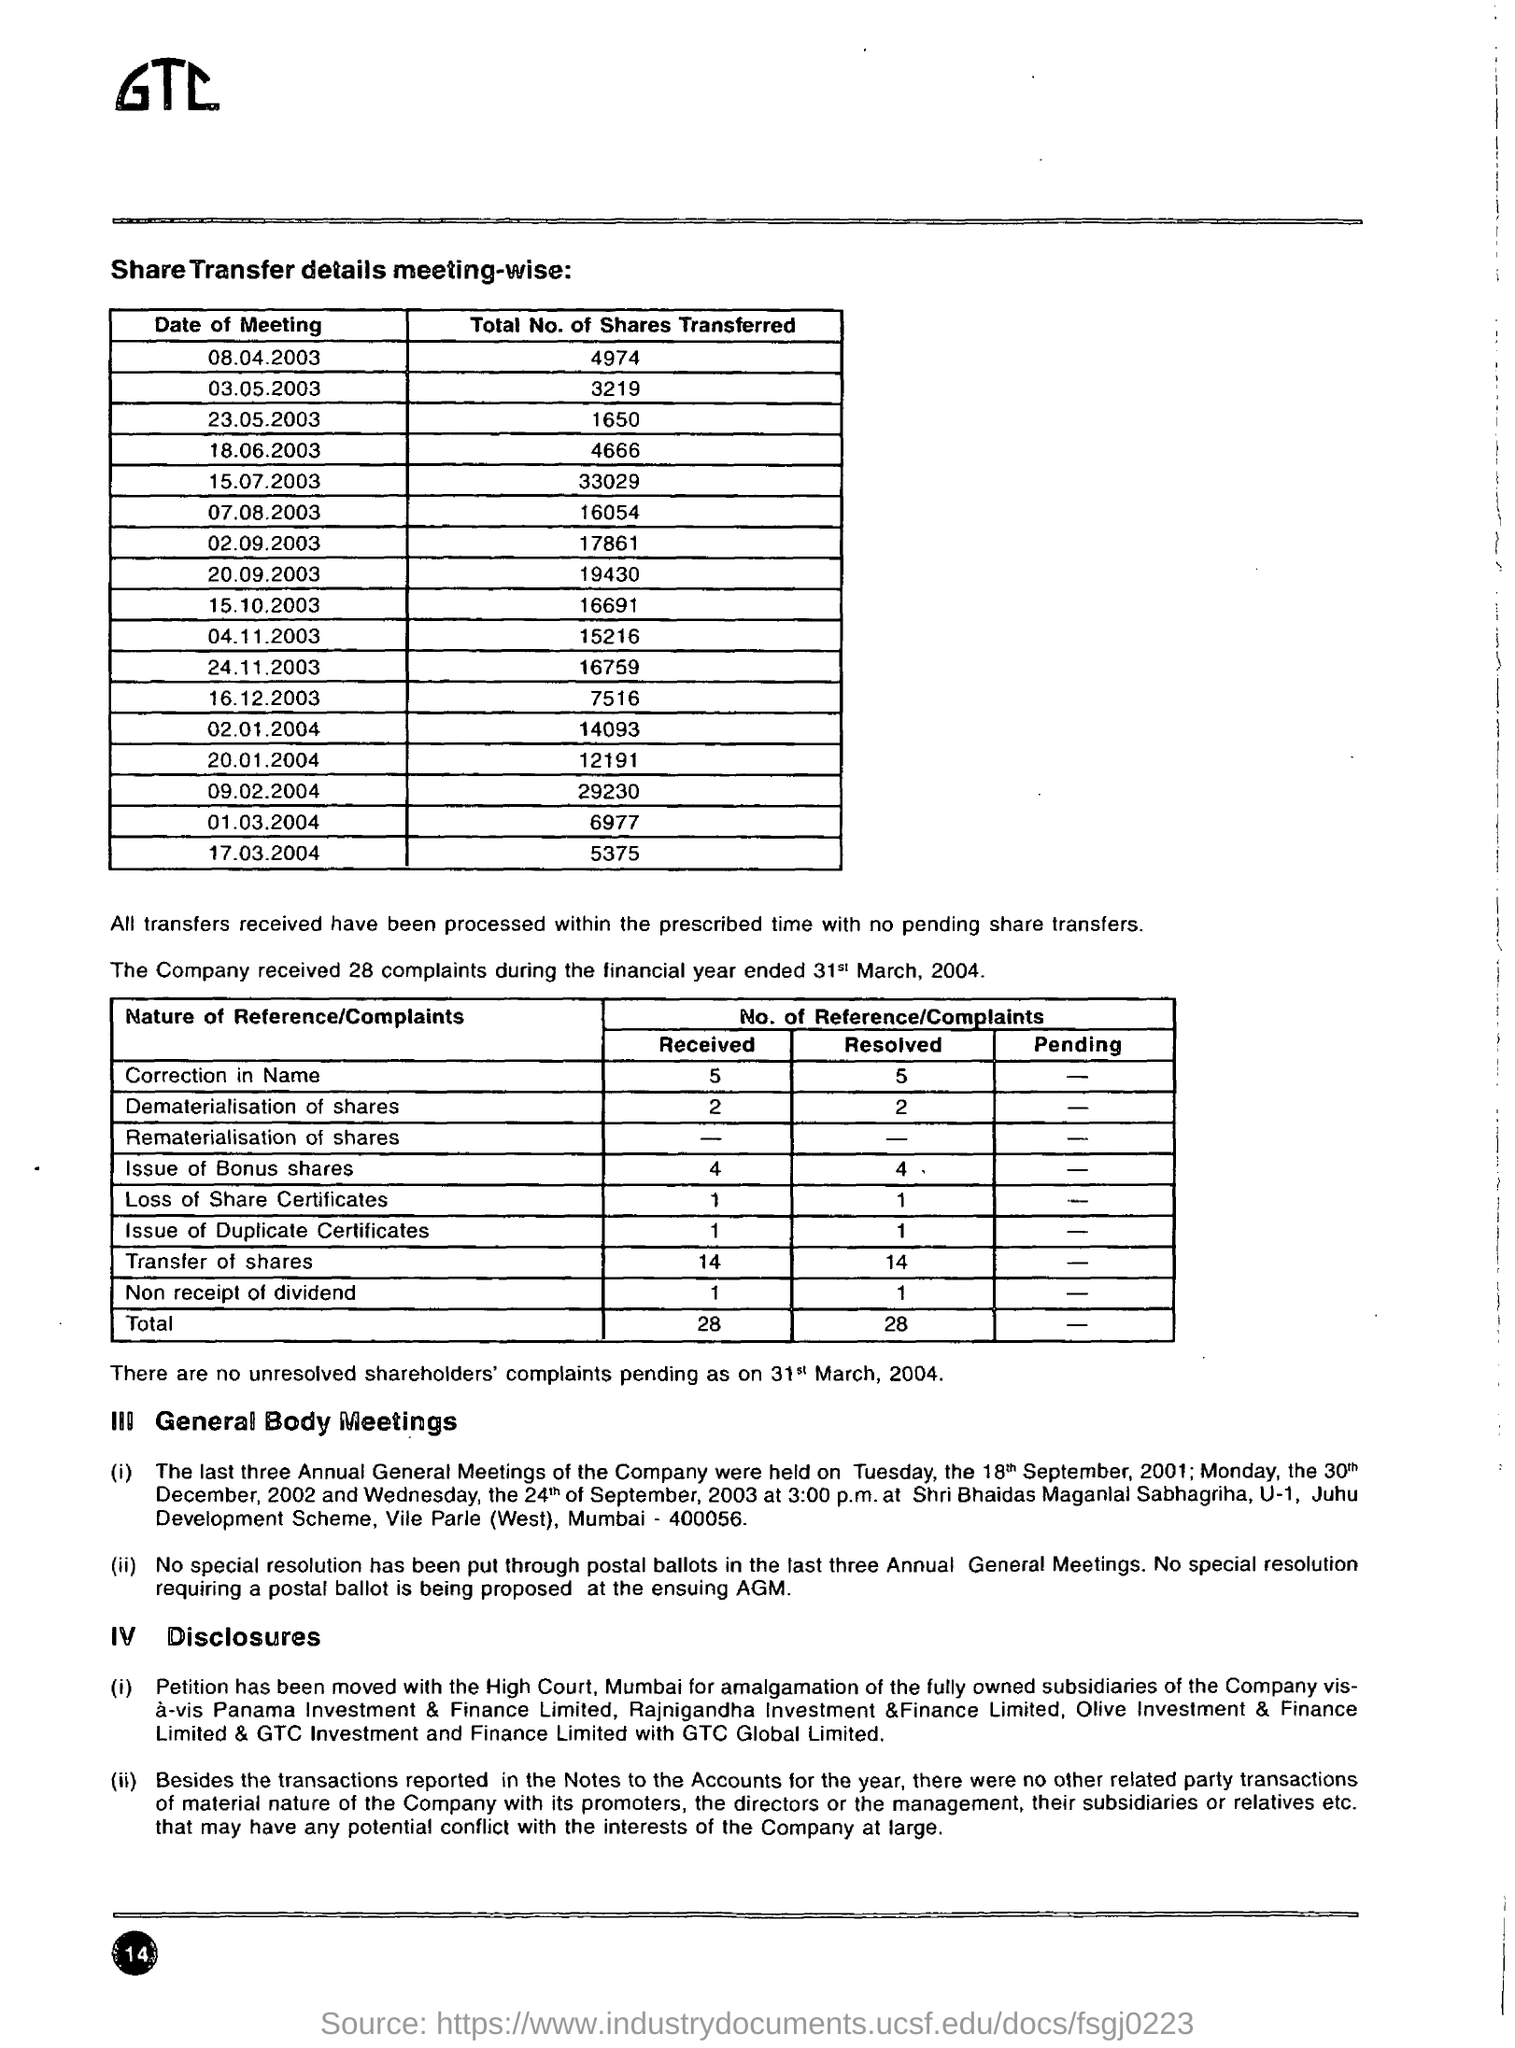Draw attention to some important aspects in this diagram. On April 8, 2003, a total of 4,974 shares were transferred. On March 17, 2004, a total of 5,375 shares were transferred. On January 20, 2004, a total of 12191 shares were transferred. During the financial year ended March 31, 2004, the company received a total of 28 complaints. On May 23, 2003, a total of 1,650 shares were transferred. 